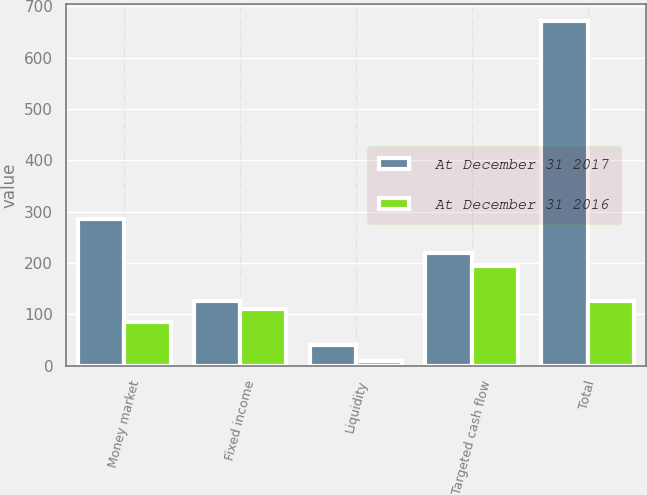Convert chart. <chart><loc_0><loc_0><loc_500><loc_500><stacked_bar_chart><ecel><fcel>Money market<fcel>Fixed income<fcel>Liquidity<fcel>Targeted cash flow<fcel>Total<nl><fcel>At December 31 2017<fcel>285<fcel>126<fcel>41<fcel>219<fcel>671<nl><fcel>At December 31 2016<fcel>86<fcel>111<fcel>9<fcel>194<fcel>126<nl></chart> 